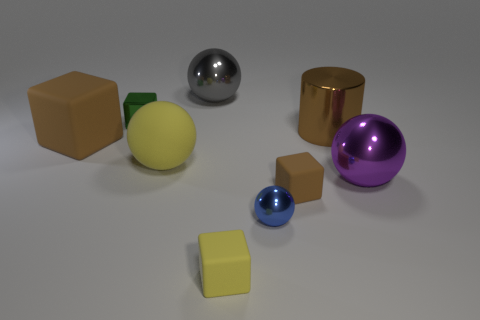What material is the big object that is to the left of the big purple sphere and on the right side of the blue metallic sphere? The big object to the left of the big purple sphere and to the right of the blue metallic sphere appears to be made of a material with a matte finish and a solid, non-reflective surface, which suggests it could be a type of plastic or painted wood. 